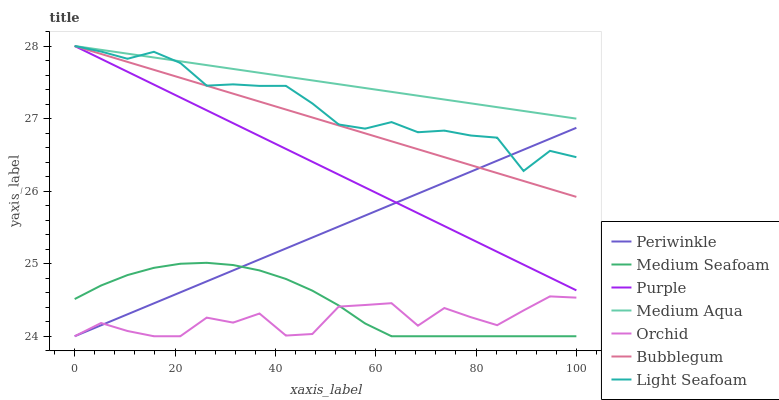Does Orchid have the minimum area under the curve?
Answer yes or no. Yes. Does Medium Aqua have the maximum area under the curve?
Answer yes or no. Yes. Does Bubblegum have the minimum area under the curve?
Answer yes or no. No. Does Bubblegum have the maximum area under the curve?
Answer yes or no. No. Is Periwinkle the smoothest?
Answer yes or no. Yes. Is Orchid the roughest?
Answer yes or no. Yes. Is Bubblegum the smoothest?
Answer yes or no. No. Is Bubblegum the roughest?
Answer yes or no. No. Does Periwinkle have the lowest value?
Answer yes or no. Yes. Does Bubblegum have the lowest value?
Answer yes or no. No. Does Light Seafoam have the highest value?
Answer yes or no. Yes. Does Periwinkle have the highest value?
Answer yes or no. No. Is Medium Seafoam less than Bubblegum?
Answer yes or no. Yes. Is Medium Aqua greater than Medium Seafoam?
Answer yes or no. Yes. Does Purple intersect Bubblegum?
Answer yes or no. Yes. Is Purple less than Bubblegum?
Answer yes or no. No. Is Purple greater than Bubblegum?
Answer yes or no. No. Does Medium Seafoam intersect Bubblegum?
Answer yes or no. No. 